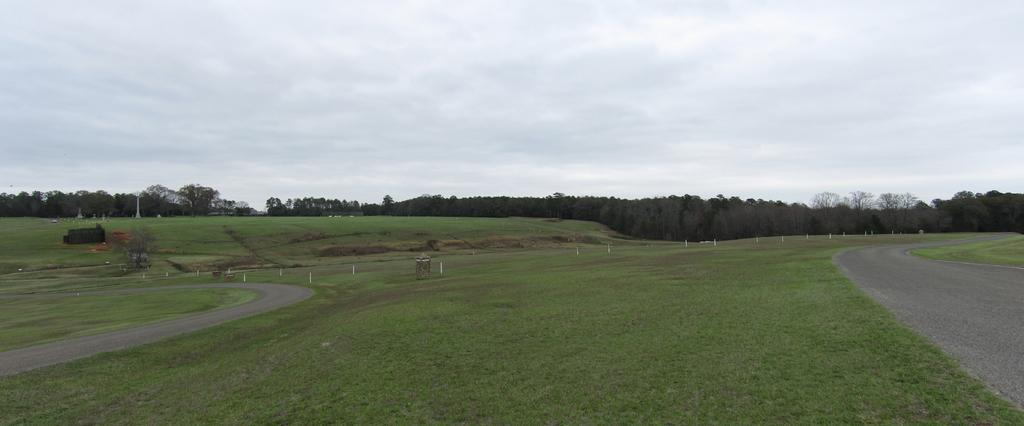In one or two sentences, can you explain what this image depicts? At the bottom of the image on the ground there is grass and also there are poles. And also there are roads. In the background there are trees. At the top of the image there is sky with clouds. 